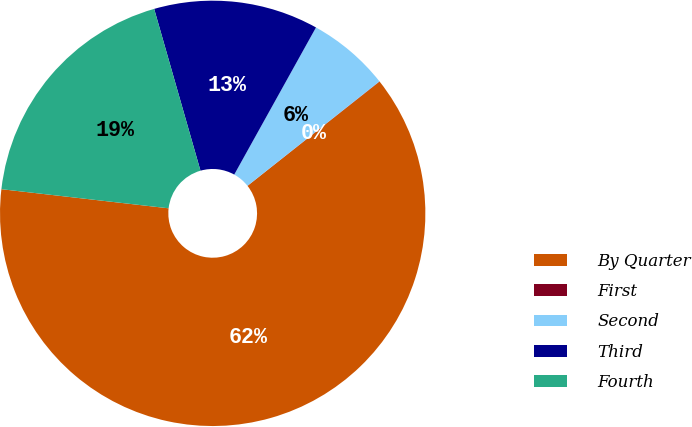Convert chart to OTSL. <chart><loc_0><loc_0><loc_500><loc_500><pie_chart><fcel>By Quarter<fcel>First<fcel>Second<fcel>Third<fcel>Fourth<nl><fcel>62.45%<fcel>0.02%<fcel>6.27%<fcel>12.51%<fcel>18.75%<nl></chart> 